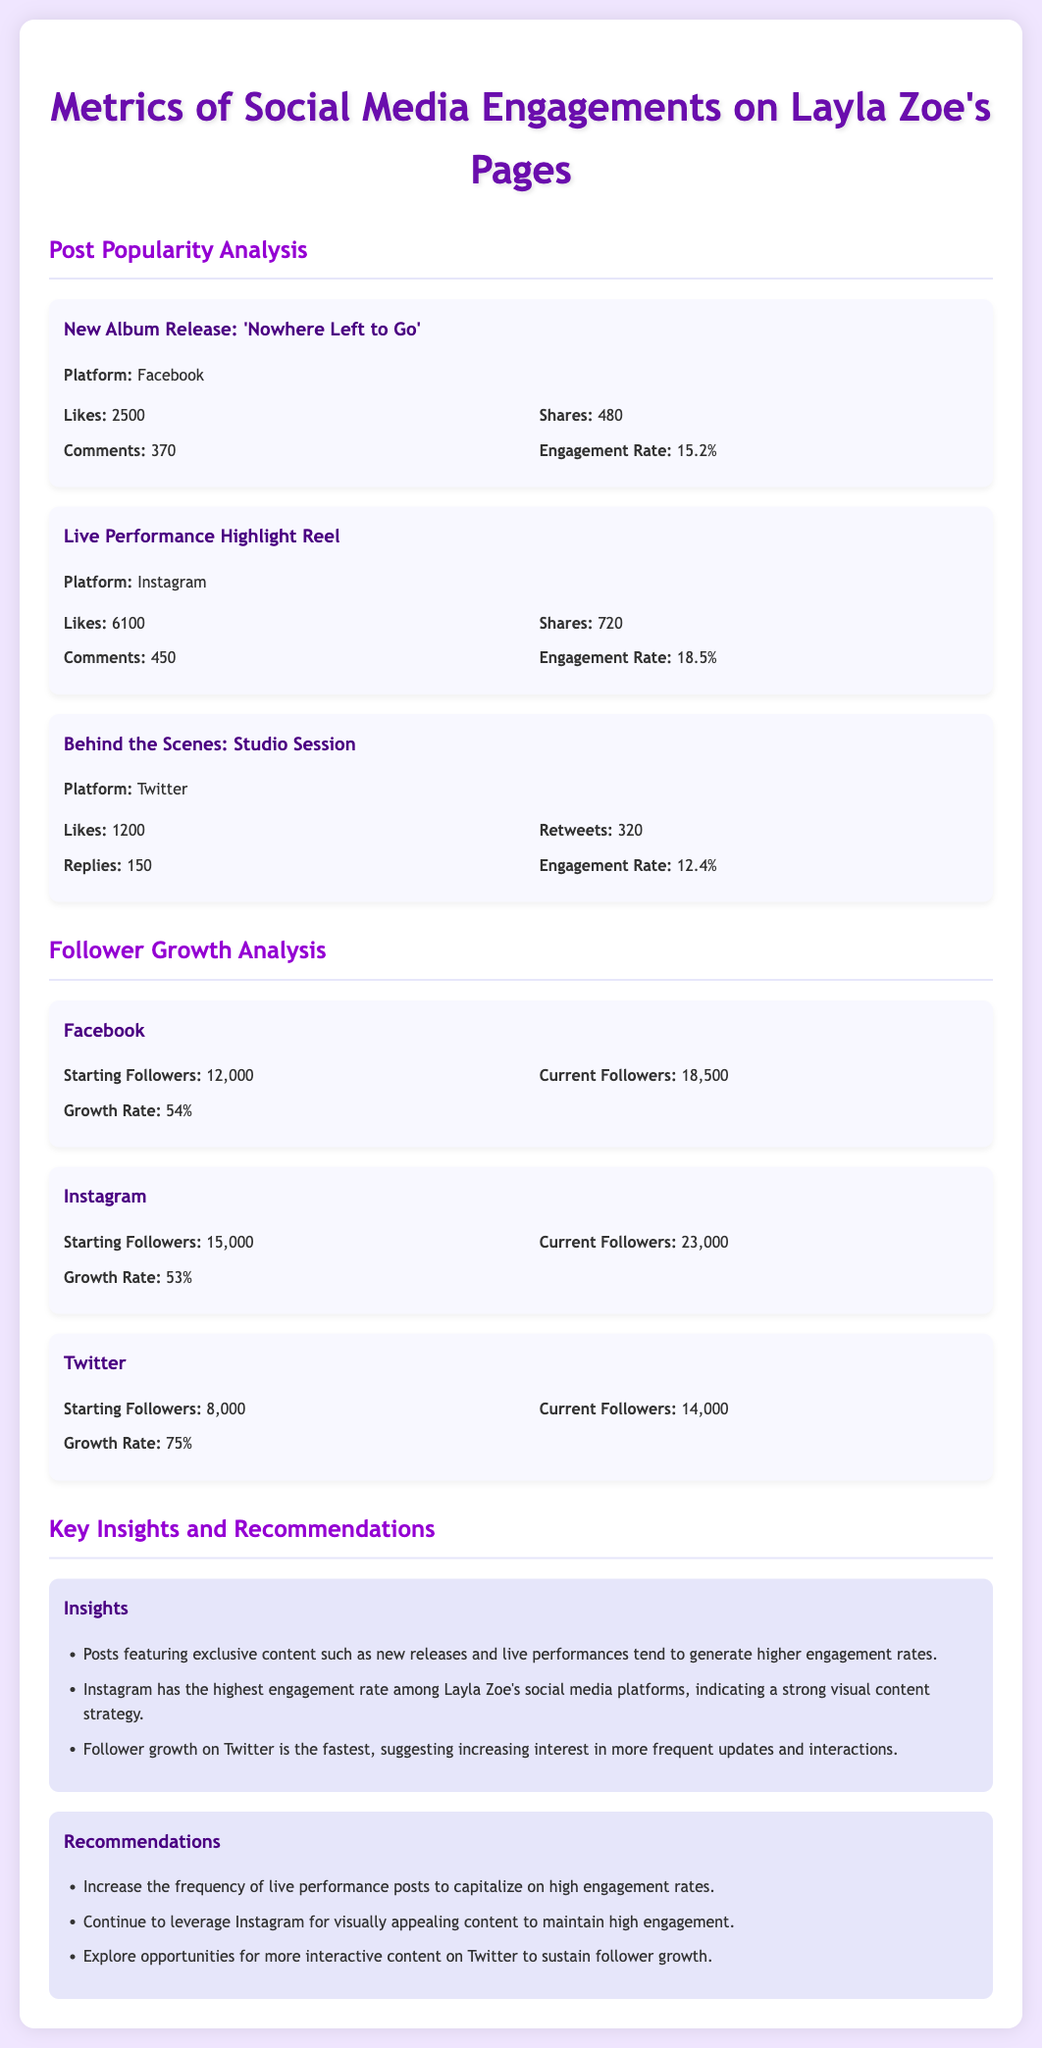What is the highest engagement rate among the posts? The highest engagement rate is found in the Live Performance Highlight Reel on Instagram, which is 18.5%.
Answer: 18.5% How many current followers does Layla Zoe have on Twitter? The current followers on Twitter are mentioned as 14,000 in the document.
Answer: 14,000 What is the starting number of followers on Instagram? The starting followers on Instagram is provided as 15,000 in the analysis.
Answer: 15,000 Which platform shows the fastest follower growth rate? The fastest growth rate is 75% on Twitter, as detailed in the follower growth section.
Answer: 75% What type of content tends to generate higher engagement rates according to the insights? The insights indicate that exclusive content such as new releases and live performances generate higher engagement rates.
Answer: Exclusive content What is the total number of likes on the new album release post? The total likes on the new album release post is stated as 2500 in the metrics.
Answer: 2500 What recommendation is made for Instagram posts? The document recommends continuing to leverage Instagram for visually appealing content to maintain high engagement.
Answer: Visually appealing content How many likes did the Behind the Scenes: Studio Session post receive? The number of likes on the Behind the Scenes post is mentioned as 1200.
Answer: 1200 What is the engagement rate of the Behind the Scenes: Studio Session post? The engagement rate for this post is specified as 12.4% in the metrics section.
Answer: 12.4% 